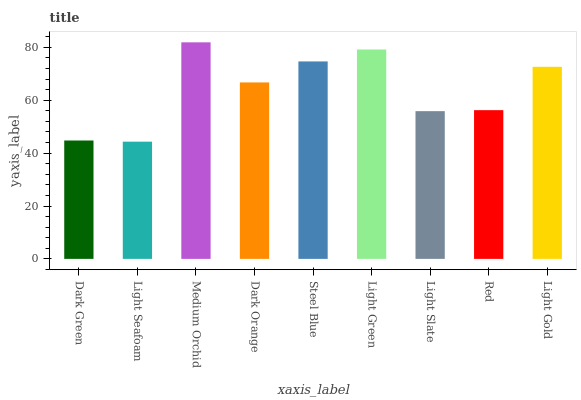Is Light Seafoam the minimum?
Answer yes or no. Yes. Is Medium Orchid the maximum?
Answer yes or no. Yes. Is Medium Orchid the minimum?
Answer yes or no. No. Is Light Seafoam the maximum?
Answer yes or no. No. Is Medium Orchid greater than Light Seafoam?
Answer yes or no. Yes. Is Light Seafoam less than Medium Orchid?
Answer yes or no. Yes. Is Light Seafoam greater than Medium Orchid?
Answer yes or no. No. Is Medium Orchid less than Light Seafoam?
Answer yes or no. No. Is Dark Orange the high median?
Answer yes or no. Yes. Is Dark Orange the low median?
Answer yes or no. Yes. Is Light Green the high median?
Answer yes or no. No. Is Light Slate the low median?
Answer yes or no. No. 